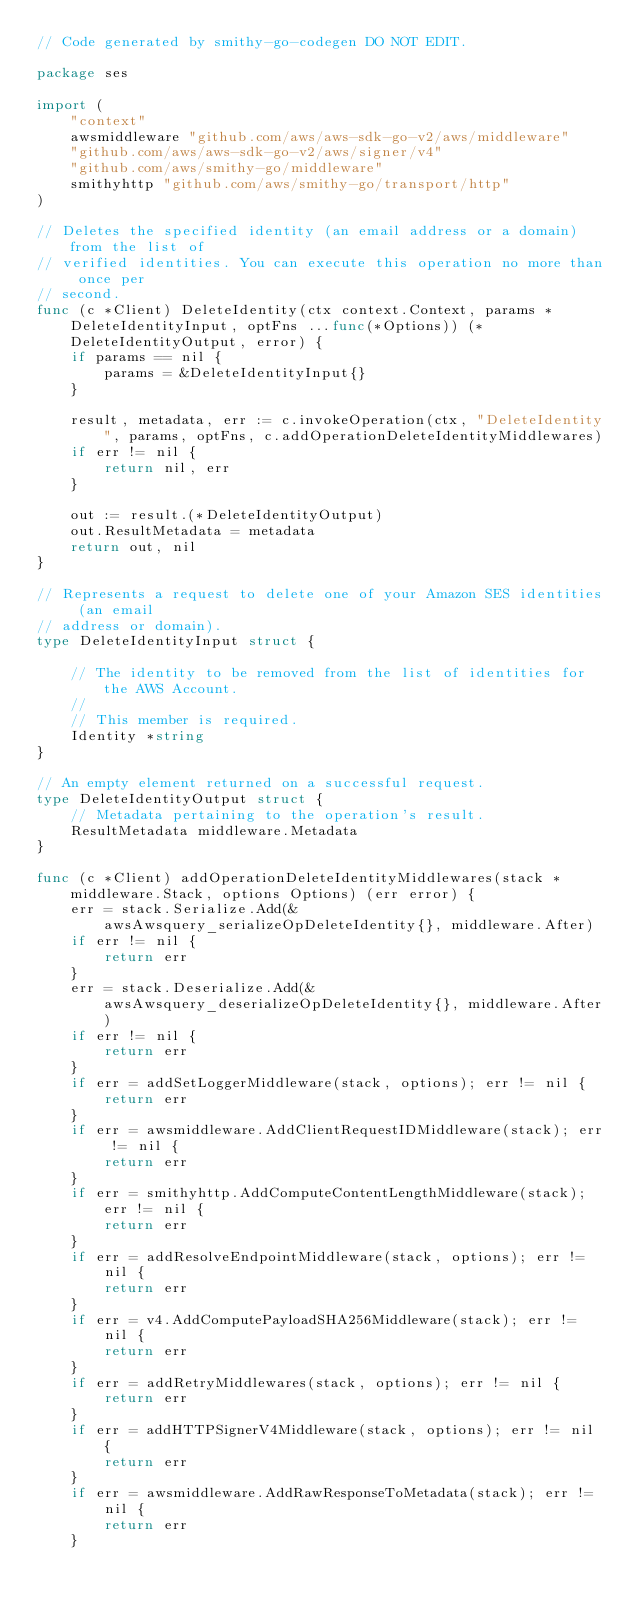Convert code to text. <code><loc_0><loc_0><loc_500><loc_500><_Go_>// Code generated by smithy-go-codegen DO NOT EDIT.

package ses

import (
	"context"
	awsmiddleware "github.com/aws/aws-sdk-go-v2/aws/middleware"
	"github.com/aws/aws-sdk-go-v2/aws/signer/v4"
	"github.com/aws/smithy-go/middleware"
	smithyhttp "github.com/aws/smithy-go/transport/http"
)

// Deletes the specified identity (an email address or a domain) from the list of
// verified identities. You can execute this operation no more than once per
// second.
func (c *Client) DeleteIdentity(ctx context.Context, params *DeleteIdentityInput, optFns ...func(*Options)) (*DeleteIdentityOutput, error) {
	if params == nil {
		params = &DeleteIdentityInput{}
	}

	result, metadata, err := c.invokeOperation(ctx, "DeleteIdentity", params, optFns, c.addOperationDeleteIdentityMiddlewares)
	if err != nil {
		return nil, err
	}

	out := result.(*DeleteIdentityOutput)
	out.ResultMetadata = metadata
	return out, nil
}

// Represents a request to delete one of your Amazon SES identities (an email
// address or domain).
type DeleteIdentityInput struct {

	// The identity to be removed from the list of identities for the AWS Account.
	//
	// This member is required.
	Identity *string
}

// An empty element returned on a successful request.
type DeleteIdentityOutput struct {
	// Metadata pertaining to the operation's result.
	ResultMetadata middleware.Metadata
}

func (c *Client) addOperationDeleteIdentityMiddlewares(stack *middleware.Stack, options Options) (err error) {
	err = stack.Serialize.Add(&awsAwsquery_serializeOpDeleteIdentity{}, middleware.After)
	if err != nil {
		return err
	}
	err = stack.Deserialize.Add(&awsAwsquery_deserializeOpDeleteIdentity{}, middleware.After)
	if err != nil {
		return err
	}
	if err = addSetLoggerMiddleware(stack, options); err != nil {
		return err
	}
	if err = awsmiddleware.AddClientRequestIDMiddleware(stack); err != nil {
		return err
	}
	if err = smithyhttp.AddComputeContentLengthMiddleware(stack); err != nil {
		return err
	}
	if err = addResolveEndpointMiddleware(stack, options); err != nil {
		return err
	}
	if err = v4.AddComputePayloadSHA256Middleware(stack); err != nil {
		return err
	}
	if err = addRetryMiddlewares(stack, options); err != nil {
		return err
	}
	if err = addHTTPSignerV4Middleware(stack, options); err != nil {
		return err
	}
	if err = awsmiddleware.AddRawResponseToMetadata(stack); err != nil {
		return err
	}</code> 